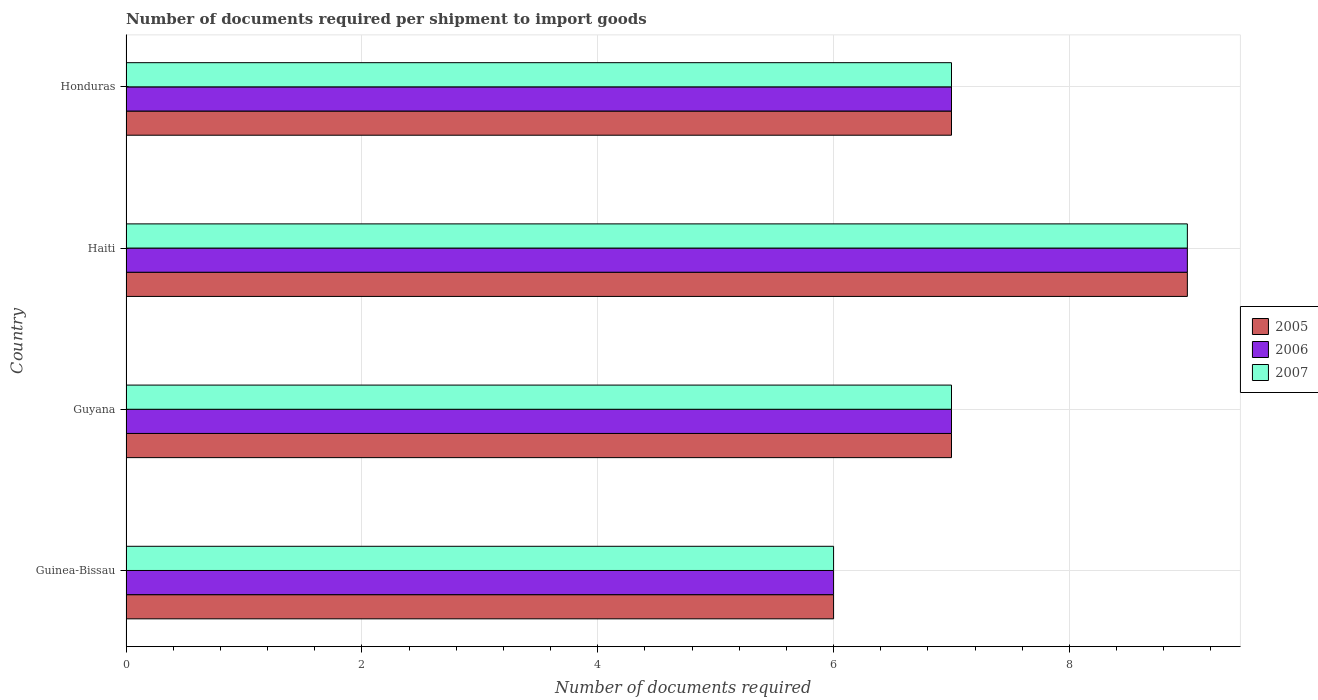Are the number of bars per tick equal to the number of legend labels?
Your answer should be compact. Yes. How many bars are there on the 4th tick from the bottom?
Your answer should be very brief. 3. What is the label of the 3rd group of bars from the top?
Your response must be concise. Guyana. In how many cases, is the number of bars for a given country not equal to the number of legend labels?
Keep it short and to the point. 0. What is the number of documents required per shipment to import goods in 2005 in Guyana?
Your answer should be very brief. 7. Across all countries, what is the minimum number of documents required per shipment to import goods in 2006?
Your answer should be compact. 6. In which country was the number of documents required per shipment to import goods in 2006 maximum?
Provide a short and direct response. Haiti. In which country was the number of documents required per shipment to import goods in 2006 minimum?
Offer a terse response. Guinea-Bissau. What is the total number of documents required per shipment to import goods in 2007 in the graph?
Provide a short and direct response. 29. What is the difference between the number of documents required per shipment to import goods in 2006 in Guyana and that in Honduras?
Provide a succinct answer. 0. What is the average number of documents required per shipment to import goods in 2007 per country?
Provide a succinct answer. 7.25. What is the difference between the number of documents required per shipment to import goods in 2005 and number of documents required per shipment to import goods in 2006 in Guinea-Bissau?
Your answer should be compact. 0. In how many countries, is the number of documents required per shipment to import goods in 2007 greater than 4 ?
Offer a terse response. 4. What is the ratio of the number of documents required per shipment to import goods in 2006 in Guyana to that in Haiti?
Offer a very short reply. 0.78. Is the difference between the number of documents required per shipment to import goods in 2005 in Guinea-Bissau and Haiti greater than the difference between the number of documents required per shipment to import goods in 2006 in Guinea-Bissau and Haiti?
Your answer should be very brief. No. What does the 3rd bar from the top in Guyana represents?
Your answer should be compact. 2005. Is it the case that in every country, the sum of the number of documents required per shipment to import goods in 2006 and number of documents required per shipment to import goods in 2005 is greater than the number of documents required per shipment to import goods in 2007?
Your response must be concise. Yes. How many countries are there in the graph?
Your response must be concise. 4. What is the difference between two consecutive major ticks on the X-axis?
Keep it short and to the point. 2. Are the values on the major ticks of X-axis written in scientific E-notation?
Offer a very short reply. No. Does the graph contain grids?
Your answer should be very brief. Yes. How many legend labels are there?
Your answer should be very brief. 3. How are the legend labels stacked?
Ensure brevity in your answer.  Vertical. What is the title of the graph?
Make the answer very short. Number of documents required per shipment to import goods. Does "1999" appear as one of the legend labels in the graph?
Give a very brief answer. No. What is the label or title of the X-axis?
Provide a short and direct response. Number of documents required. What is the label or title of the Y-axis?
Your answer should be very brief. Country. What is the Number of documents required in 2005 in Guinea-Bissau?
Your answer should be very brief. 6. What is the Number of documents required in 2006 in Guyana?
Your answer should be compact. 7. What is the Number of documents required in 2007 in Guyana?
Ensure brevity in your answer.  7. Across all countries, what is the minimum Number of documents required in 2006?
Your answer should be compact. 6. Across all countries, what is the minimum Number of documents required of 2007?
Offer a very short reply. 6. What is the total Number of documents required in 2005 in the graph?
Ensure brevity in your answer.  29. What is the total Number of documents required in 2006 in the graph?
Make the answer very short. 29. What is the difference between the Number of documents required of 2005 in Guinea-Bissau and that in Guyana?
Offer a terse response. -1. What is the difference between the Number of documents required of 2006 in Guinea-Bissau and that in Guyana?
Keep it short and to the point. -1. What is the difference between the Number of documents required in 2007 in Guinea-Bissau and that in Guyana?
Give a very brief answer. -1. What is the difference between the Number of documents required of 2006 in Guinea-Bissau and that in Haiti?
Offer a very short reply. -3. What is the difference between the Number of documents required in 2006 in Guyana and that in Haiti?
Provide a short and direct response. -2. What is the difference between the Number of documents required of 2005 in Haiti and that in Honduras?
Your response must be concise. 2. What is the difference between the Number of documents required of 2005 in Guinea-Bissau and the Number of documents required of 2007 in Haiti?
Provide a short and direct response. -3. What is the difference between the Number of documents required in 2006 in Guinea-Bissau and the Number of documents required in 2007 in Haiti?
Ensure brevity in your answer.  -3. What is the difference between the Number of documents required of 2005 in Guyana and the Number of documents required of 2006 in Haiti?
Keep it short and to the point. -2. What is the difference between the Number of documents required in 2005 in Guyana and the Number of documents required in 2006 in Honduras?
Your answer should be compact. 0. What is the difference between the Number of documents required in 2005 in Haiti and the Number of documents required in 2006 in Honduras?
Your answer should be compact. 2. What is the difference between the Number of documents required in 2006 in Haiti and the Number of documents required in 2007 in Honduras?
Your response must be concise. 2. What is the average Number of documents required of 2005 per country?
Offer a very short reply. 7.25. What is the average Number of documents required in 2006 per country?
Provide a succinct answer. 7.25. What is the average Number of documents required of 2007 per country?
Offer a terse response. 7.25. What is the difference between the Number of documents required in 2005 and Number of documents required in 2006 in Guinea-Bissau?
Make the answer very short. 0. What is the difference between the Number of documents required of 2006 and Number of documents required of 2007 in Guyana?
Ensure brevity in your answer.  0. What is the difference between the Number of documents required of 2005 and Number of documents required of 2006 in Haiti?
Provide a succinct answer. 0. What is the difference between the Number of documents required in 2006 and Number of documents required in 2007 in Haiti?
Your answer should be very brief. 0. What is the difference between the Number of documents required of 2005 and Number of documents required of 2006 in Honduras?
Your answer should be compact. 0. What is the ratio of the Number of documents required in 2007 in Guinea-Bissau to that in Guyana?
Ensure brevity in your answer.  0.86. What is the ratio of the Number of documents required in 2005 in Guinea-Bissau to that in Haiti?
Your answer should be compact. 0.67. What is the ratio of the Number of documents required of 2007 in Guinea-Bissau to that in Haiti?
Provide a succinct answer. 0.67. What is the ratio of the Number of documents required in 2005 in Guinea-Bissau to that in Honduras?
Your answer should be very brief. 0.86. What is the ratio of the Number of documents required in 2007 in Guinea-Bissau to that in Honduras?
Keep it short and to the point. 0.86. What is the ratio of the Number of documents required in 2007 in Guyana to that in Haiti?
Your answer should be very brief. 0.78. What is the ratio of the Number of documents required of 2006 in Haiti to that in Honduras?
Provide a short and direct response. 1.29. What is the ratio of the Number of documents required of 2007 in Haiti to that in Honduras?
Offer a very short reply. 1.29. What is the difference between the highest and the lowest Number of documents required in 2005?
Your answer should be very brief. 3. What is the difference between the highest and the lowest Number of documents required of 2007?
Provide a succinct answer. 3. 